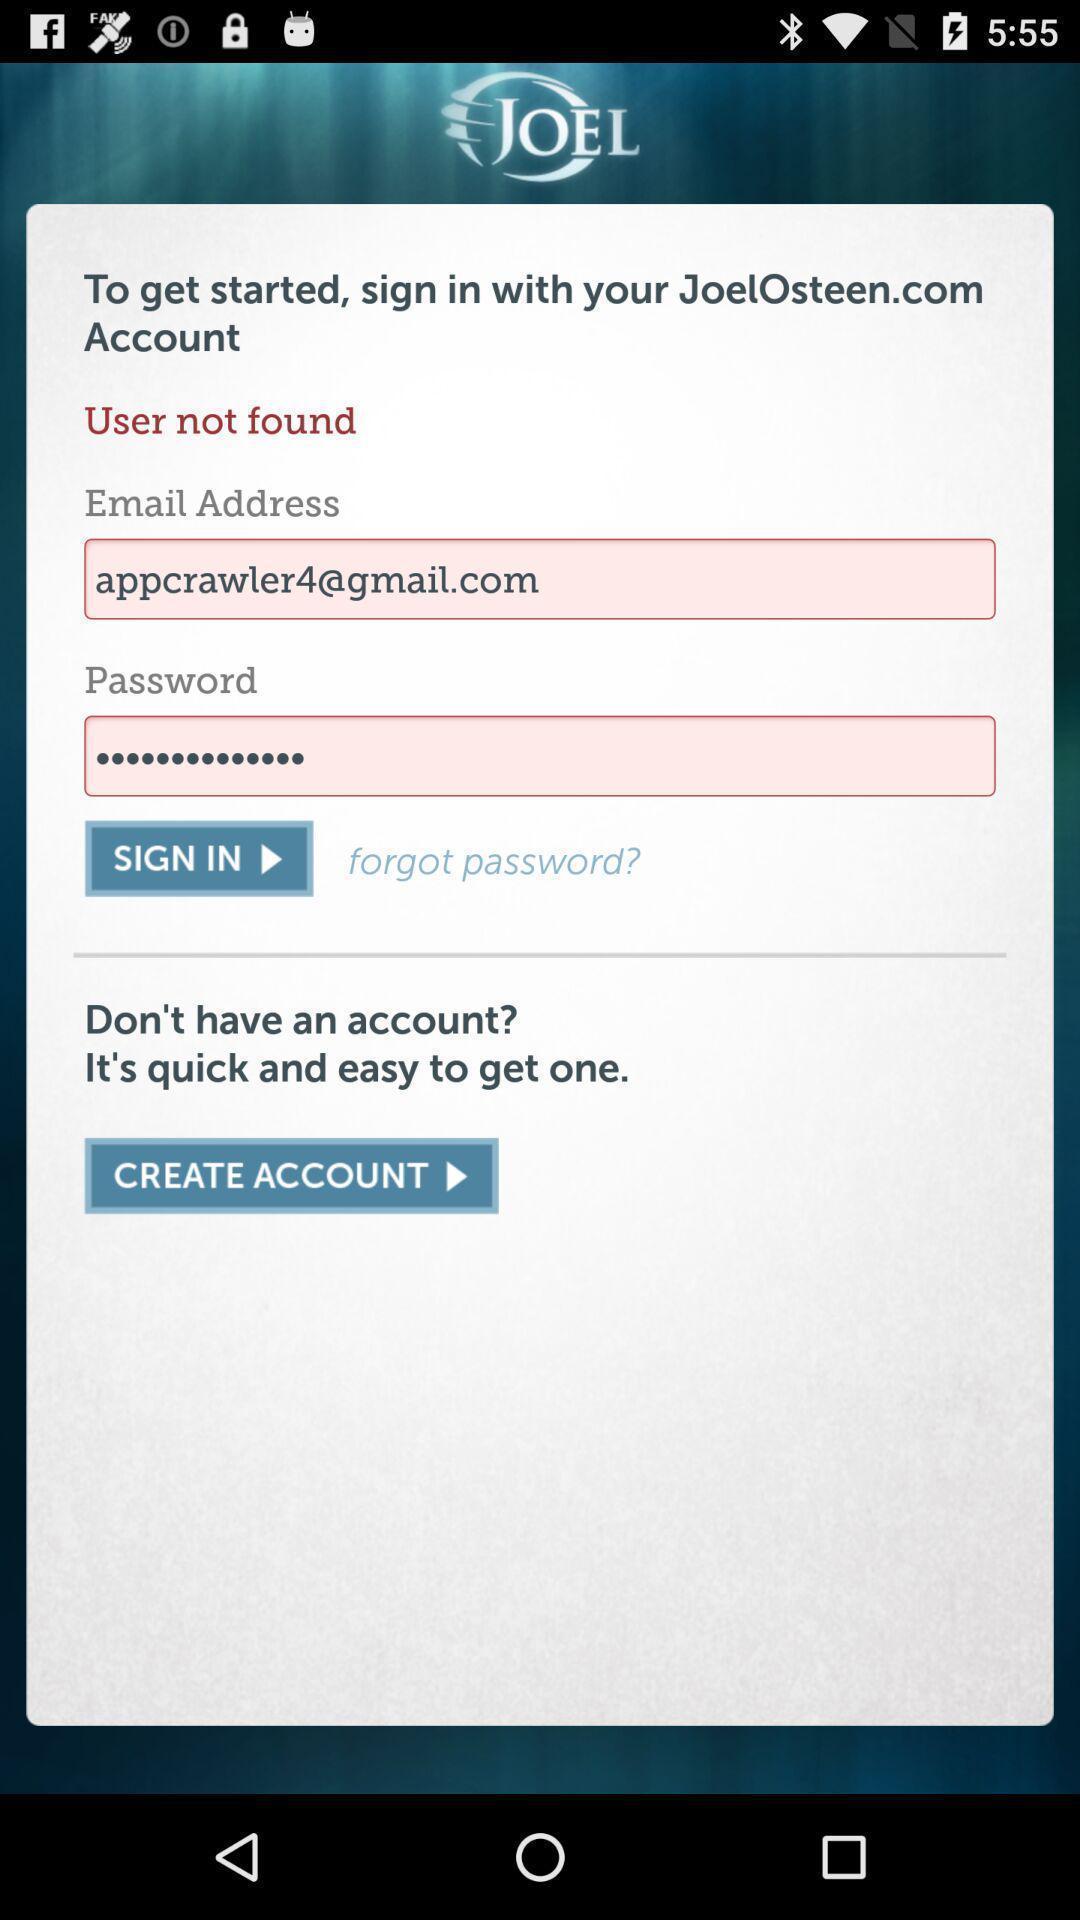Describe the key features of this screenshot. Sign in page of the page. 